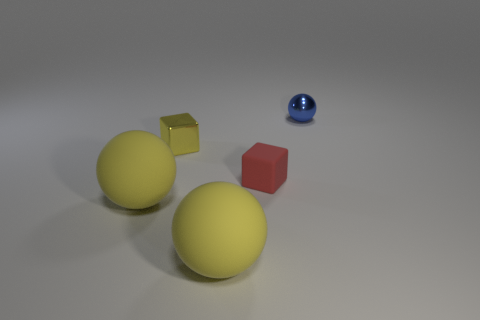Can you describe the lighting and shadows visible in the scene? The image depicts a softly lit scene with diffuse lighting, creating gentle shadows that extend to the right of the objects. This lighting suggests an ambient light source possibly located to the top left, giving the image a calm and even tone. 